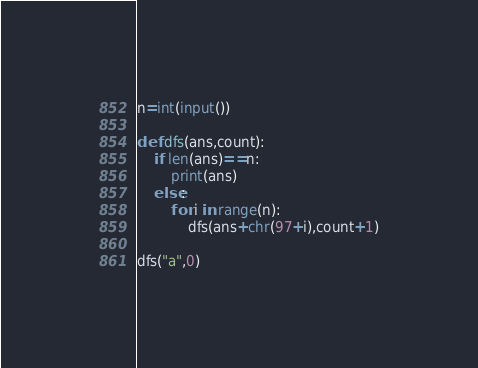<code> <loc_0><loc_0><loc_500><loc_500><_Python_>n=int(input())

def dfs(ans,count):
    if len(ans)==n:
        print(ans)
    else:
        for i in range(n):
            dfs(ans+chr(97+i),count+1)

dfs("a",0)
</code> 